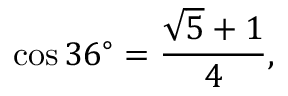<formula> <loc_0><loc_0><loc_500><loc_500>\cos 3 6 ^ { \circ } = { \frac { { \sqrt { 5 } } + 1 } { 4 } } ,</formula> 